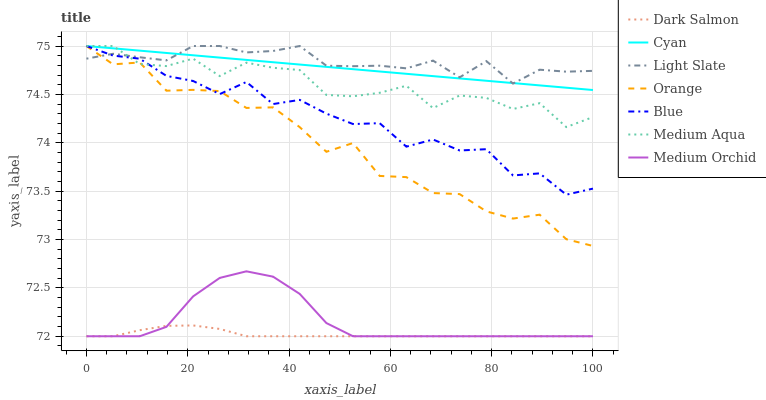Does Dark Salmon have the minimum area under the curve?
Answer yes or no. Yes. Does Light Slate have the maximum area under the curve?
Answer yes or no. Yes. Does Medium Orchid have the minimum area under the curve?
Answer yes or no. No. Does Medium Orchid have the maximum area under the curve?
Answer yes or no. No. Is Cyan the smoothest?
Answer yes or no. Yes. Is Orange the roughest?
Answer yes or no. Yes. Is Light Slate the smoothest?
Answer yes or no. No. Is Light Slate the roughest?
Answer yes or no. No. Does Medium Orchid have the lowest value?
Answer yes or no. Yes. Does Light Slate have the lowest value?
Answer yes or no. No. Does Cyan have the highest value?
Answer yes or no. Yes. Does Medium Orchid have the highest value?
Answer yes or no. No. Is Dark Salmon less than Light Slate?
Answer yes or no. Yes. Is Medium Aqua greater than Dark Salmon?
Answer yes or no. Yes. Does Orange intersect Light Slate?
Answer yes or no. Yes. Is Orange less than Light Slate?
Answer yes or no. No. Is Orange greater than Light Slate?
Answer yes or no. No. Does Dark Salmon intersect Light Slate?
Answer yes or no. No. 